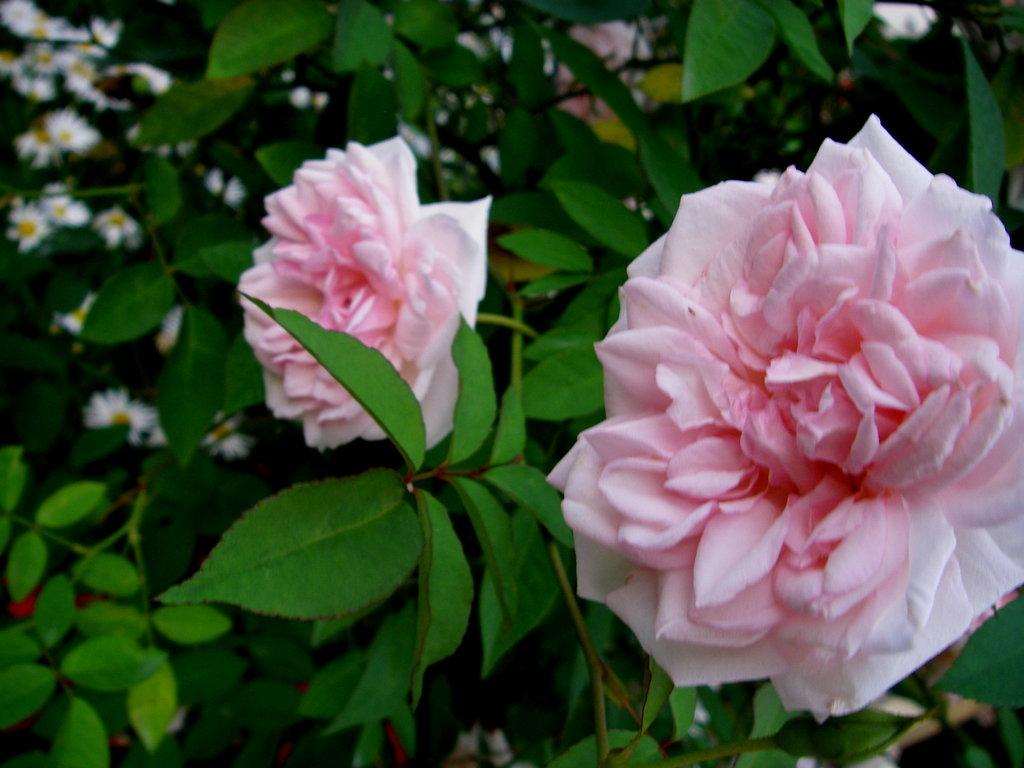What type of living organisms can be seen in the image? Plants can be seen in the image. What color are the flowers on the plants? There are white flowers and pink flowers in the image. How would you describe the background of the image? The background of the image is slightly blurred. What is the name of the daughter in the image? There is no daughter present in the image; it features plants with white and pink flowers. How many thumbs can be seen in the image? There are no thumbs visible in the image, as it features plants and flowers. 